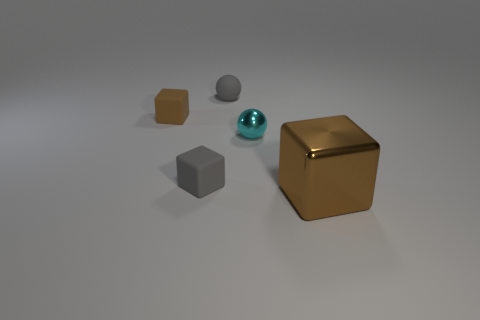Does the gray matte object in front of the gray ball have the same shape as the brown object that is left of the small gray rubber sphere?
Offer a very short reply. Yes. There is a brown matte thing that is the same size as the cyan metal sphere; what is its shape?
Provide a short and direct response. Cube. What number of metallic things are either small balls or tiny brown objects?
Your response must be concise. 1. Do the gray object in front of the small metal thing and the cube that is behind the tiny cyan ball have the same material?
Give a very brief answer. Yes. There is a sphere that is made of the same material as the tiny brown block; what is its color?
Provide a short and direct response. Gray. Is the number of cubes that are in front of the cyan ball greater than the number of cyan things that are in front of the large cube?
Offer a very short reply. Yes. Are there any cyan things?
Provide a succinct answer. Yes. What is the material of the tiny thing that is the same color as the big metal block?
Keep it short and to the point. Rubber. How many objects are either gray matte objects or tiny gray balls?
Your answer should be very brief. 2. Are there any big blocks of the same color as the tiny metallic thing?
Your response must be concise. No. 